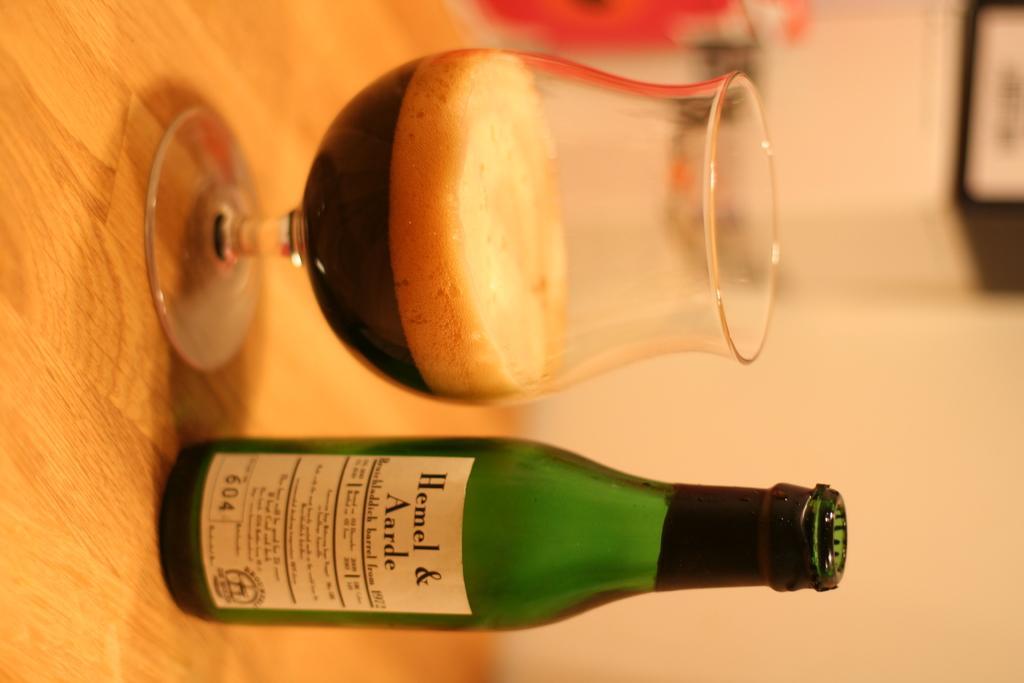Describe this image in one or two sentences. vIn this image we can see a green color bottle and glass with drink in it placed on the table. 